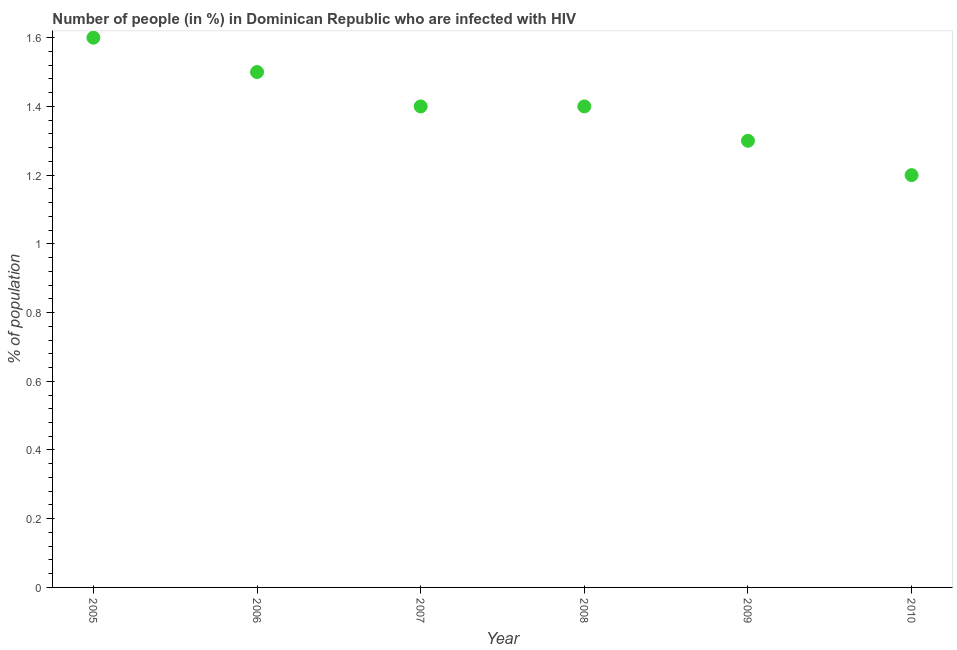What is the number of people infected with hiv in 2005?
Offer a terse response. 1.6. Across all years, what is the maximum number of people infected with hiv?
Make the answer very short. 1.6. What is the sum of the number of people infected with hiv?
Give a very brief answer. 8.4. What is the difference between the number of people infected with hiv in 2005 and 2007?
Your answer should be compact. 0.2. What is the average number of people infected with hiv per year?
Your answer should be compact. 1.4. What is the median number of people infected with hiv?
Your answer should be very brief. 1.4. In how many years, is the number of people infected with hiv greater than 0.92 %?
Provide a succinct answer. 6. Do a majority of the years between 2010 and 2008 (inclusive) have number of people infected with hiv greater than 0.9600000000000001 %?
Give a very brief answer. No. What is the ratio of the number of people infected with hiv in 2006 to that in 2007?
Offer a terse response. 1.07. Is the number of people infected with hiv in 2006 less than that in 2008?
Offer a terse response. No. Is the difference between the number of people infected with hiv in 2005 and 2007 greater than the difference between any two years?
Your answer should be very brief. No. What is the difference between the highest and the second highest number of people infected with hiv?
Your answer should be very brief. 0.1. Is the sum of the number of people infected with hiv in 2006 and 2009 greater than the maximum number of people infected with hiv across all years?
Ensure brevity in your answer.  Yes. What is the difference between the highest and the lowest number of people infected with hiv?
Your answer should be compact. 0.4. Does the number of people infected with hiv monotonically increase over the years?
Offer a very short reply. No. What is the difference between two consecutive major ticks on the Y-axis?
Offer a terse response. 0.2. Does the graph contain grids?
Make the answer very short. No. What is the title of the graph?
Offer a very short reply. Number of people (in %) in Dominican Republic who are infected with HIV. What is the label or title of the Y-axis?
Ensure brevity in your answer.  % of population. What is the % of population in 2006?
Your response must be concise. 1.5. What is the % of population in 2007?
Your response must be concise. 1.4. What is the difference between the % of population in 2005 and 2006?
Keep it short and to the point. 0.1. What is the difference between the % of population in 2005 and 2008?
Give a very brief answer. 0.2. What is the difference between the % of population in 2006 and 2007?
Keep it short and to the point. 0.1. What is the difference between the % of population in 2006 and 2009?
Offer a terse response. 0.2. What is the difference between the % of population in 2006 and 2010?
Offer a terse response. 0.3. What is the difference between the % of population in 2007 and 2008?
Provide a short and direct response. 0. What is the difference between the % of population in 2007 and 2010?
Provide a short and direct response. 0.2. What is the difference between the % of population in 2008 and 2009?
Offer a very short reply. 0.1. What is the difference between the % of population in 2009 and 2010?
Ensure brevity in your answer.  0.1. What is the ratio of the % of population in 2005 to that in 2006?
Offer a very short reply. 1.07. What is the ratio of the % of population in 2005 to that in 2007?
Offer a very short reply. 1.14. What is the ratio of the % of population in 2005 to that in 2008?
Make the answer very short. 1.14. What is the ratio of the % of population in 2005 to that in 2009?
Provide a succinct answer. 1.23. What is the ratio of the % of population in 2005 to that in 2010?
Your answer should be very brief. 1.33. What is the ratio of the % of population in 2006 to that in 2007?
Offer a terse response. 1.07. What is the ratio of the % of population in 2006 to that in 2008?
Provide a succinct answer. 1.07. What is the ratio of the % of population in 2006 to that in 2009?
Offer a terse response. 1.15. What is the ratio of the % of population in 2006 to that in 2010?
Offer a terse response. 1.25. What is the ratio of the % of population in 2007 to that in 2009?
Offer a very short reply. 1.08. What is the ratio of the % of population in 2007 to that in 2010?
Your answer should be very brief. 1.17. What is the ratio of the % of population in 2008 to that in 2009?
Your answer should be very brief. 1.08. What is the ratio of the % of population in 2008 to that in 2010?
Offer a terse response. 1.17. What is the ratio of the % of population in 2009 to that in 2010?
Provide a short and direct response. 1.08. 